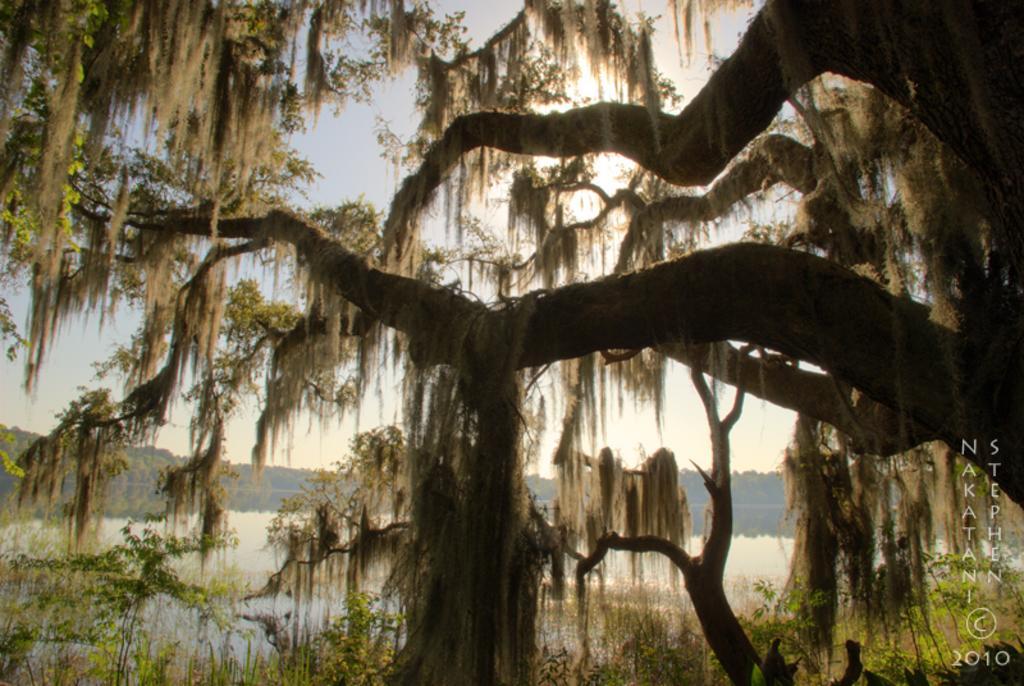How would you summarize this image in a sentence or two? In this picture we can see there are trees, lake and the sky. On the image there is a watermark. 